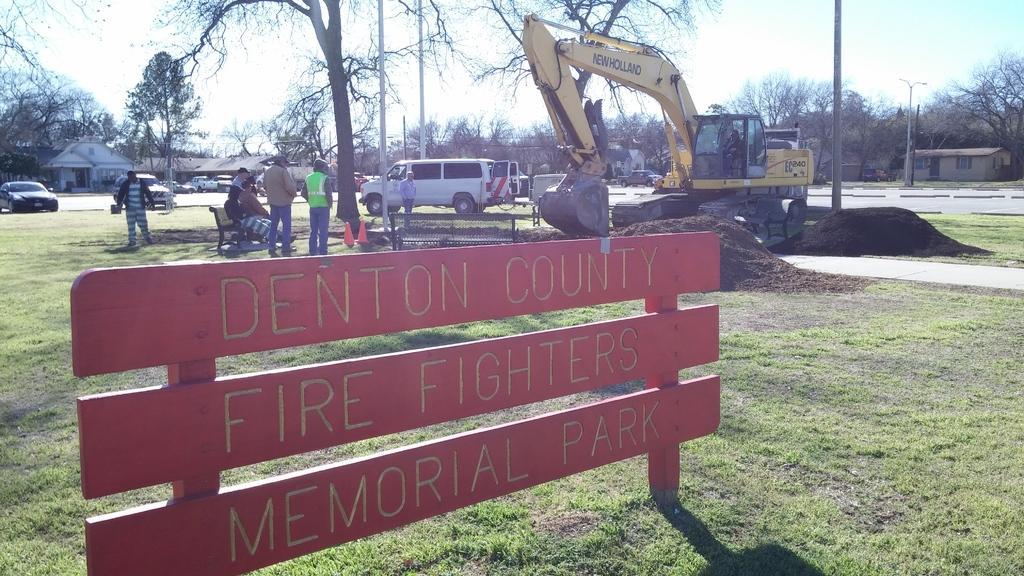How would you summarize this image in a sentence or two? At the bottom of the image there is a board. In the background there are people standing and some of them are sitting. On the right there is a crane excavating and we can see cars on the road. In the background there are buildings, trees, poles and sky. 